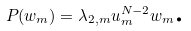Convert formula to latex. <formula><loc_0><loc_0><loc_500><loc_500>P ( w _ { m } ) = \lambda _ { 2 , m } u _ { m } ^ { N - 2 } w _ { m } \text {.}</formula> 